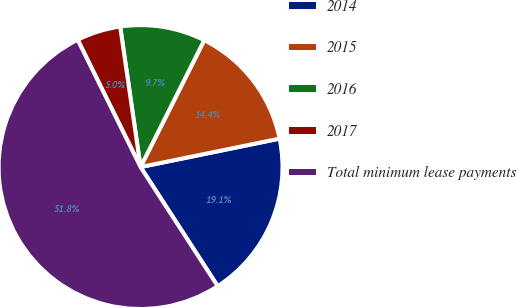<chart> <loc_0><loc_0><loc_500><loc_500><pie_chart><fcel>2014<fcel>2015<fcel>2016<fcel>2017<fcel>Total minimum lease payments<nl><fcel>19.06%<fcel>14.38%<fcel>9.7%<fcel>5.01%<fcel>51.84%<nl></chart> 